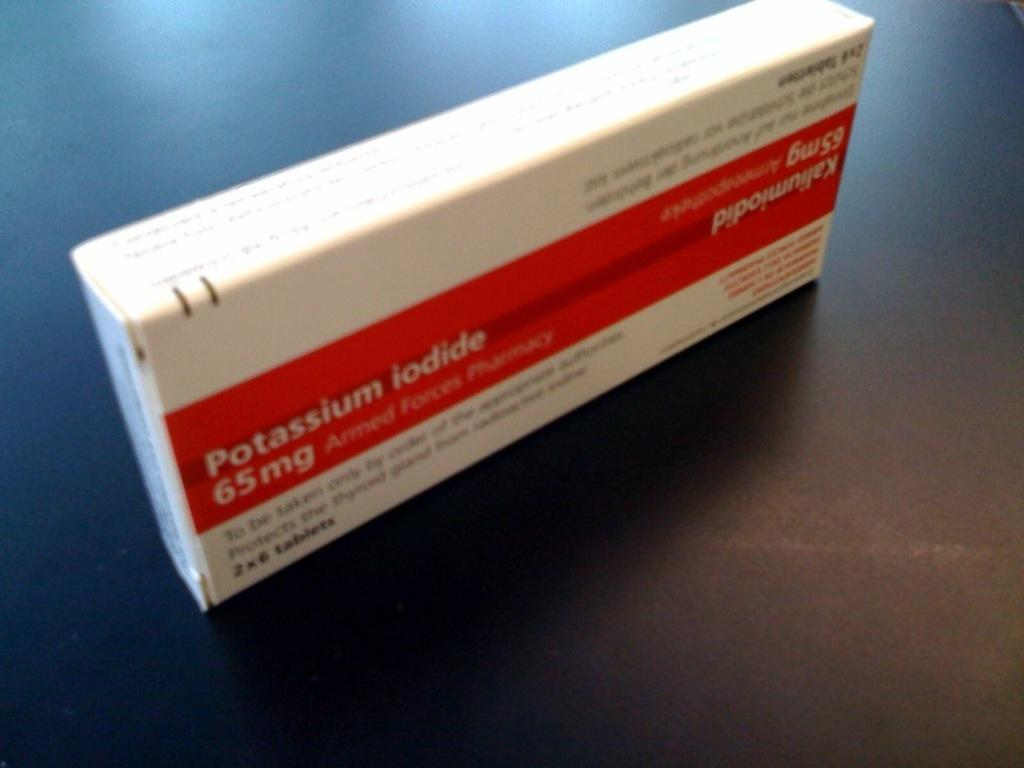What is the color of the surface in the image? The surface in the image is black. What is placed on the black surface? There is a white box on the black surface. Is there any text or writing on the white box? Yes, there is writing on the white box. What type of pie is being served on the black surface in the image? There is no pie present in the image; it features a white box with writing on a black surface. 